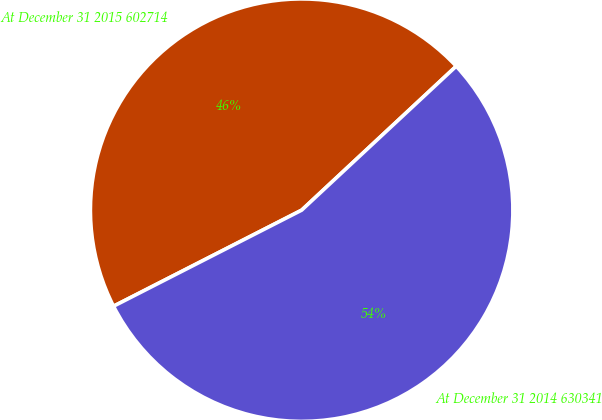Convert chart. <chart><loc_0><loc_0><loc_500><loc_500><pie_chart><fcel>At December 31 2015 602714<fcel>At December 31 2014 630341<nl><fcel>45.58%<fcel>54.42%<nl></chart> 